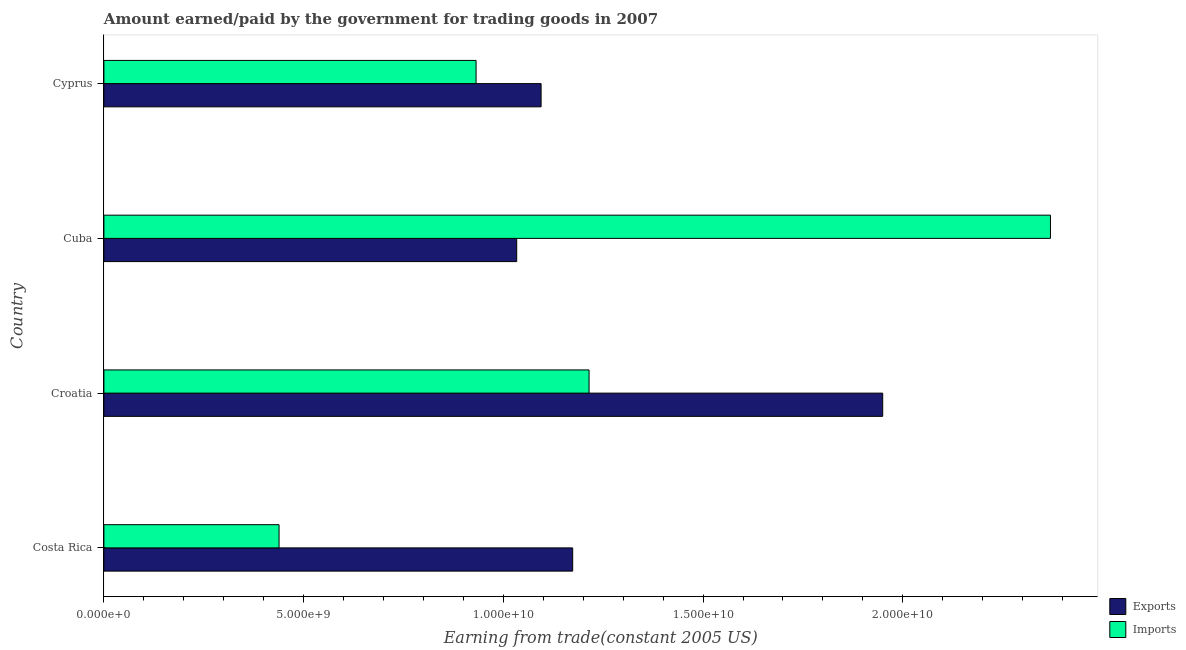How many different coloured bars are there?
Offer a terse response. 2. Are the number of bars per tick equal to the number of legend labels?
Ensure brevity in your answer.  Yes. How many bars are there on the 2nd tick from the bottom?
Give a very brief answer. 2. What is the label of the 2nd group of bars from the top?
Provide a short and direct response. Cuba. In how many cases, is the number of bars for a given country not equal to the number of legend labels?
Make the answer very short. 0. What is the amount paid for imports in Cuba?
Provide a succinct answer. 2.37e+1. Across all countries, what is the maximum amount paid for imports?
Ensure brevity in your answer.  2.37e+1. Across all countries, what is the minimum amount earned from exports?
Offer a terse response. 1.03e+1. In which country was the amount earned from exports maximum?
Your answer should be very brief. Croatia. What is the total amount earned from exports in the graph?
Offer a terse response. 5.25e+1. What is the difference between the amount paid for imports in Cuba and that in Cyprus?
Your answer should be compact. 1.44e+1. What is the difference between the amount earned from exports in Cyprus and the amount paid for imports in Cuba?
Provide a succinct answer. -1.28e+1. What is the average amount earned from exports per country?
Your answer should be very brief. 1.31e+1. What is the difference between the amount earned from exports and amount paid for imports in Croatia?
Ensure brevity in your answer.  7.35e+09. What is the ratio of the amount earned from exports in Costa Rica to that in Cuba?
Offer a terse response. 1.14. What is the difference between the highest and the second highest amount paid for imports?
Offer a very short reply. 1.16e+1. What is the difference between the highest and the lowest amount paid for imports?
Your answer should be compact. 1.93e+1. Is the sum of the amount earned from exports in Cuba and Cyprus greater than the maximum amount paid for imports across all countries?
Your response must be concise. No. What does the 2nd bar from the top in Cuba represents?
Keep it short and to the point. Exports. What does the 1st bar from the bottom in Croatia represents?
Your answer should be very brief. Exports. How many bars are there?
Keep it short and to the point. 8. How many countries are there in the graph?
Your answer should be compact. 4. Are the values on the major ticks of X-axis written in scientific E-notation?
Your answer should be very brief. Yes. Does the graph contain any zero values?
Your answer should be very brief. No. Does the graph contain grids?
Your answer should be very brief. No. How many legend labels are there?
Provide a succinct answer. 2. What is the title of the graph?
Make the answer very short. Amount earned/paid by the government for trading goods in 2007. Does "Commercial service imports" appear as one of the legend labels in the graph?
Offer a terse response. No. What is the label or title of the X-axis?
Make the answer very short. Earning from trade(constant 2005 US). What is the label or title of the Y-axis?
Keep it short and to the point. Country. What is the Earning from trade(constant 2005 US) of Exports in Costa Rica?
Your response must be concise. 1.17e+1. What is the Earning from trade(constant 2005 US) in Imports in Costa Rica?
Offer a very short reply. 4.39e+09. What is the Earning from trade(constant 2005 US) of Exports in Croatia?
Give a very brief answer. 1.95e+1. What is the Earning from trade(constant 2005 US) of Imports in Croatia?
Provide a succinct answer. 1.21e+1. What is the Earning from trade(constant 2005 US) in Exports in Cuba?
Your response must be concise. 1.03e+1. What is the Earning from trade(constant 2005 US) of Imports in Cuba?
Offer a very short reply. 2.37e+1. What is the Earning from trade(constant 2005 US) of Exports in Cyprus?
Offer a terse response. 1.09e+1. What is the Earning from trade(constant 2005 US) in Imports in Cyprus?
Your response must be concise. 9.32e+09. Across all countries, what is the maximum Earning from trade(constant 2005 US) of Exports?
Give a very brief answer. 1.95e+1. Across all countries, what is the maximum Earning from trade(constant 2005 US) in Imports?
Your answer should be very brief. 2.37e+1. Across all countries, what is the minimum Earning from trade(constant 2005 US) of Exports?
Provide a short and direct response. 1.03e+1. Across all countries, what is the minimum Earning from trade(constant 2005 US) of Imports?
Provide a succinct answer. 4.39e+09. What is the total Earning from trade(constant 2005 US) in Exports in the graph?
Give a very brief answer. 5.25e+1. What is the total Earning from trade(constant 2005 US) in Imports in the graph?
Offer a very short reply. 4.95e+1. What is the difference between the Earning from trade(constant 2005 US) of Exports in Costa Rica and that in Croatia?
Provide a succinct answer. -7.76e+09. What is the difference between the Earning from trade(constant 2005 US) of Imports in Costa Rica and that in Croatia?
Provide a succinct answer. -7.76e+09. What is the difference between the Earning from trade(constant 2005 US) in Exports in Costa Rica and that in Cuba?
Keep it short and to the point. 1.40e+09. What is the difference between the Earning from trade(constant 2005 US) in Imports in Costa Rica and that in Cuba?
Give a very brief answer. -1.93e+1. What is the difference between the Earning from trade(constant 2005 US) in Exports in Costa Rica and that in Cyprus?
Offer a very short reply. 7.91e+08. What is the difference between the Earning from trade(constant 2005 US) in Imports in Costa Rica and that in Cyprus?
Provide a short and direct response. -4.93e+09. What is the difference between the Earning from trade(constant 2005 US) in Exports in Croatia and that in Cuba?
Your answer should be very brief. 9.16e+09. What is the difference between the Earning from trade(constant 2005 US) in Imports in Croatia and that in Cuba?
Ensure brevity in your answer.  -1.16e+1. What is the difference between the Earning from trade(constant 2005 US) in Exports in Croatia and that in Cyprus?
Your answer should be very brief. 8.55e+09. What is the difference between the Earning from trade(constant 2005 US) of Imports in Croatia and that in Cyprus?
Your answer should be compact. 2.83e+09. What is the difference between the Earning from trade(constant 2005 US) in Exports in Cuba and that in Cyprus?
Give a very brief answer. -6.10e+08. What is the difference between the Earning from trade(constant 2005 US) of Imports in Cuba and that in Cyprus?
Offer a terse response. 1.44e+1. What is the difference between the Earning from trade(constant 2005 US) of Exports in Costa Rica and the Earning from trade(constant 2005 US) of Imports in Croatia?
Provide a succinct answer. -4.10e+08. What is the difference between the Earning from trade(constant 2005 US) in Exports in Costa Rica and the Earning from trade(constant 2005 US) in Imports in Cuba?
Offer a terse response. -1.20e+1. What is the difference between the Earning from trade(constant 2005 US) in Exports in Costa Rica and the Earning from trade(constant 2005 US) in Imports in Cyprus?
Your answer should be very brief. 2.42e+09. What is the difference between the Earning from trade(constant 2005 US) of Exports in Croatia and the Earning from trade(constant 2005 US) of Imports in Cuba?
Ensure brevity in your answer.  -4.20e+09. What is the difference between the Earning from trade(constant 2005 US) in Exports in Croatia and the Earning from trade(constant 2005 US) in Imports in Cyprus?
Offer a terse response. 1.02e+1. What is the difference between the Earning from trade(constant 2005 US) in Exports in Cuba and the Earning from trade(constant 2005 US) in Imports in Cyprus?
Your answer should be very brief. 1.02e+09. What is the average Earning from trade(constant 2005 US) of Exports per country?
Offer a terse response. 1.31e+1. What is the average Earning from trade(constant 2005 US) in Imports per country?
Ensure brevity in your answer.  1.24e+1. What is the difference between the Earning from trade(constant 2005 US) in Exports and Earning from trade(constant 2005 US) in Imports in Costa Rica?
Your answer should be very brief. 7.35e+09. What is the difference between the Earning from trade(constant 2005 US) of Exports and Earning from trade(constant 2005 US) of Imports in Croatia?
Offer a terse response. 7.35e+09. What is the difference between the Earning from trade(constant 2005 US) of Exports and Earning from trade(constant 2005 US) of Imports in Cuba?
Make the answer very short. -1.34e+1. What is the difference between the Earning from trade(constant 2005 US) in Exports and Earning from trade(constant 2005 US) in Imports in Cyprus?
Your response must be concise. 1.63e+09. What is the ratio of the Earning from trade(constant 2005 US) of Exports in Costa Rica to that in Croatia?
Ensure brevity in your answer.  0.6. What is the ratio of the Earning from trade(constant 2005 US) in Imports in Costa Rica to that in Croatia?
Make the answer very short. 0.36. What is the ratio of the Earning from trade(constant 2005 US) of Exports in Costa Rica to that in Cuba?
Make the answer very short. 1.14. What is the ratio of the Earning from trade(constant 2005 US) of Imports in Costa Rica to that in Cuba?
Ensure brevity in your answer.  0.19. What is the ratio of the Earning from trade(constant 2005 US) of Exports in Costa Rica to that in Cyprus?
Your answer should be compact. 1.07. What is the ratio of the Earning from trade(constant 2005 US) of Imports in Costa Rica to that in Cyprus?
Give a very brief answer. 0.47. What is the ratio of the Earning from trade(constant 2005 US) in Exports in Croatia to that in Cuba?
Provide a short and direct response. 1.89. What is the ratio of the Earning from trade(constant 2005 US) of Imports in Croatia to that in Cuba?
Your answer should be compact. 0.51. What is the ratio of the Earning from trade(constant 2005 US) in Exports in Croatia to that in Cyprus?
Your response must be concise. 1.78. What is the ratio of the Earning from trade(constant 2005 US) of Imports in Croatia to that in Cyprus?
Your response must be concise. 1.3. What is the ratio of the Earning from trade(constant 2005 US) of Exports in Cuba to that in Cyprus?
Your response must be concise. 0.94. What is the ratio of the Earning from trade(constant 2005 US) in Imports in Cuba to that in Cyprus?
Your response must be concise. 2.54. What is the difference between the highest and the second highest Earning from trade(constant 2005 US) in Exports?
Provide a succinct answer. 7.76e+09. What is the difference between the highest and the second highest Earning from trade(constant 2005 US) of Imports?
Ensure brevity in your answer.  1.16e+1. What is the difference between the highest and the lowest Earning from trade(constant 2005 US) in Exports?
Give a very brief answer. 9.16e+09. What is the difference between the highest and the lowest Earning from trade(constant 2005 US) in Imports?
Give a very brief answer. 1.93e+1. 